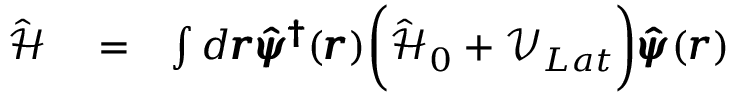Convert formula to latex. <formula><loc_0><loc_0><loc_500><loc_500>\begin{array} { r l r } { \hat { \mathcal { H } } } & = } & { \int d \pm b { r } \pm b { \hat { \psi } ^ { \dag } } ( \pm b { r } ) \left ( \hat { \mathcal { H } } _ { 0 } + \mathcal { V } _ { L a t } \right ) \pm b { \hat { \psi } } ( \pm b { r } ) } \end{array}</formula> 